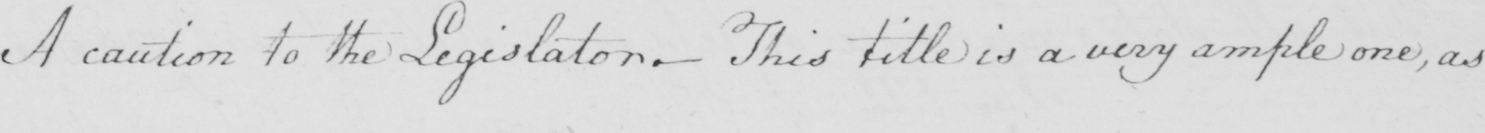What is written in this line of handwriting? A caution to the Legislator _  This title is a very ample one , as 